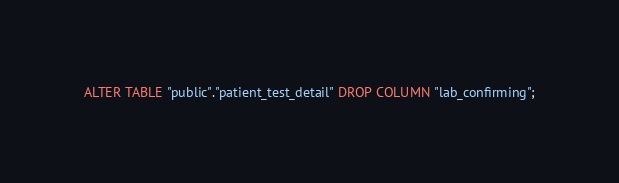<code> <loc_0><loc_0><loc_500><loc_500><_SQL_>ALTER TABLE "public"."patient_test_detail" DROP COLUMN "lab_confirming";
</code> 